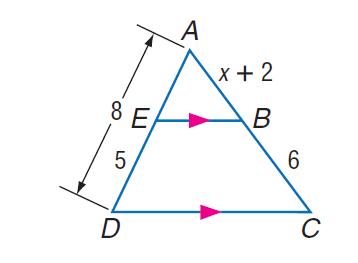Answer the mathemtical geometry problem and directly provide the correct option letter.
Question: Find A B.
Choices: A: 1.6 B: 2.8 C: 3.6 D: 4 C 